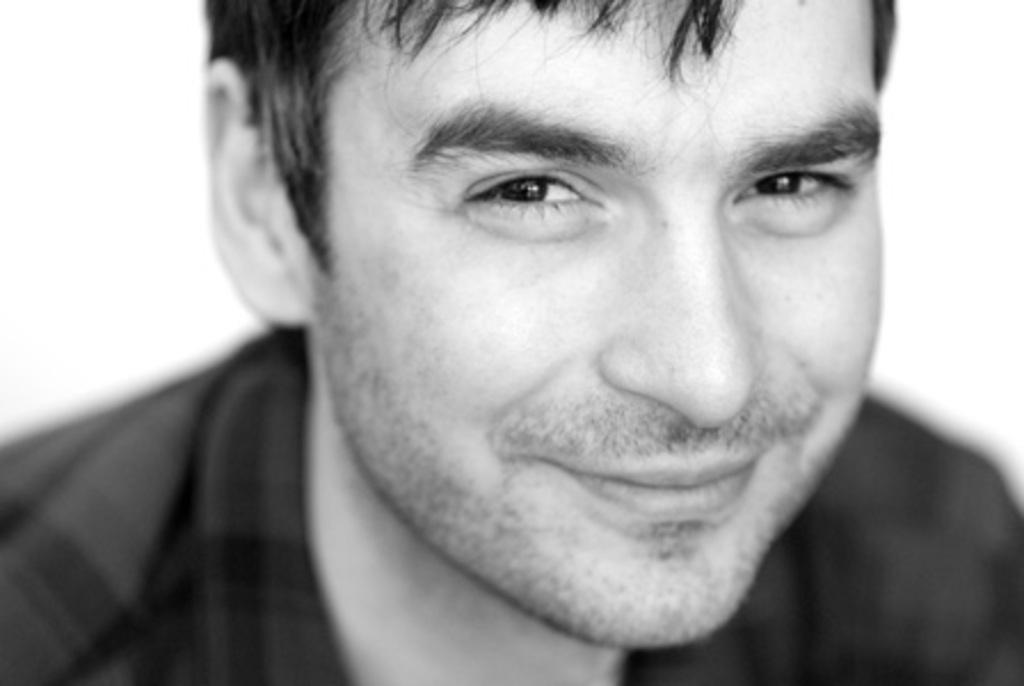Describe this image in one or two sentences. This picture is a black and white image. In this image we can see one man with a smiling face and there is a white background. 